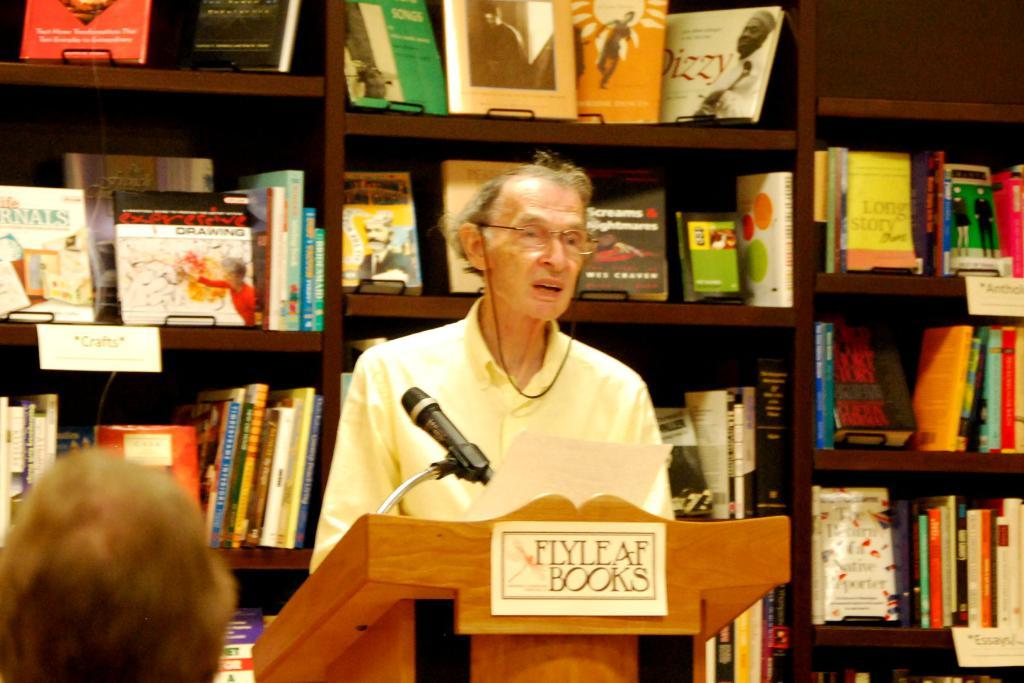<image>
Describe the image concisely. A man speaks behind a podium with a Flyle AF Books on a sign. 